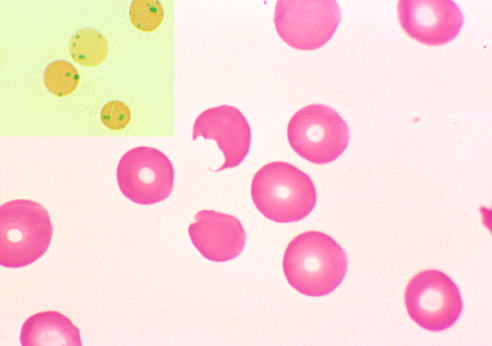do the splenic macrophages pluck out these inclusions?
Answer the question using a single word or phrase. Yes 